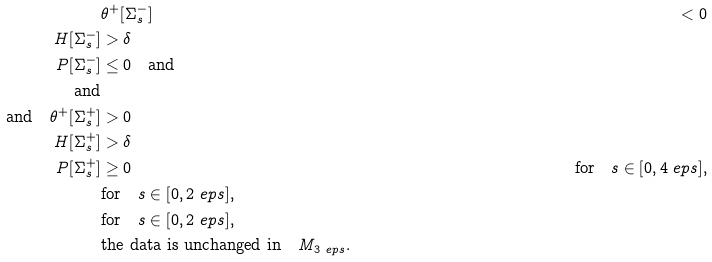<formula> <loc_0><loc_0><loc_500><loc_500>& \theta ^ { + } [ \Sigma ^ { - } _ { s } ] & < 0 \\ H [ \Sigma ^ { - } _ { s } ] & > \delta \\ P [ \Sigma ^ { - } _ { s } ] & \leq 0 \quad \text {and} \\ \text {and} \\ \text {and} \quad \theta ^ { + } [ \Sigma ^ { + } _ { s } ] & > 0 \\ H [ \Sigma ^ { + } _ { s } ] & > \delta \\ P [ \Sigma ^ { + } _ { s } ] & \geq 0 \quad & \text {for} \quad s \in [ 0 , 4 \ e p s ] , \\ & \text {for} \quad s \in [ 0 , 2 \ e p s ] , \\ & \text {for} \quad s \in [ 0 , 2 \ e p s ] , \\ & \text {the data is unchanged in} \quad M _ { 3 \ e p s } .</formula> 